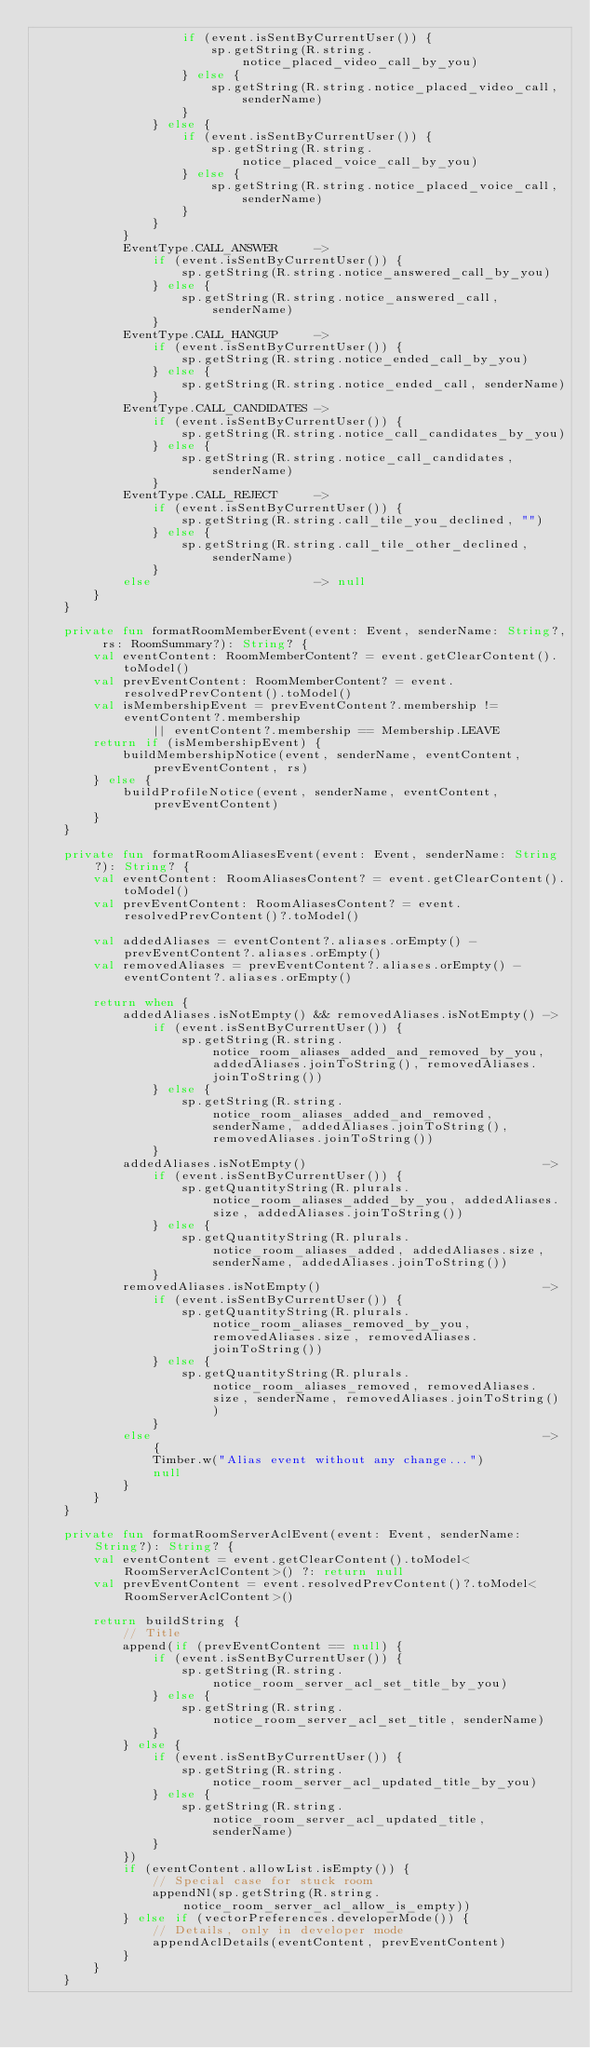Convert code to text. <code><loc_0><loc_0><loc_500><loc_500><_Kotlin_>                    if (event.isSentByCurrentUser()) {
                        sp.getString(R.string.notice_placed_video_call_by_you)
                    } else {
                        sp.getString(R.string.notice_placed_video_call, senderName)
                    }
                } else {
                    if (event.isSentByCurrentUser()) {
                        sp.getString(R.string.notice_placed_voice_call_by_you)
                    } else {
                        sp.getString(R.string.notice_placed_voice_call, senderName)
                    }
                }
            }
            EventType.CALL_ANSWER     ->
                if (event.isSentByCurrentUser()) {
                    sp.getString(R.string.notice_answered_call_by_you)
                } else {
                    sp.getString(R.string.notice_answered_call, senderName)
                }
            EventType.CALL_HANGUP     ->
                if (event.isSentByCurrentUser()) {
                    sp.getString(R.string.notice_ended_call_by_you)
                } else {
                    sp.getString(R.string.notice_ended_call, senderName)
                }
            EventType.CALL_CANDIDATES ->
                if (event.isSentByCurrentUser()) {
                    sp.getString(R.string.notice_call_candidates_by_you)
                } else {
                    sp.getString(R.string.notice_call_candidates, senderName)
                }
            EventType.CALL_REJECT     ->
                if (event.isSentByCurrentUser()) {
                    sp.getString(R.string.call_tile_you_declined, "")
                } else {
                    sp.getString(R.string.call_tile_other_declined, senderName)
                }
            else                      -> null
        }
    }

    private fun formatRoomMemberEvent(event: Event, senderName: String?, rs: RoomSummary?): String? {
        val eventContent: RoomMemberContent? = event.getClearContent().toModel()
        val prevEventContent: RoomMemberContent? = event.resolvedPrevContent().toModel()
        val isMembershipEvent = prevEventContent?.membership != eventContent?.membership
                || eventContent?.membership == Membership.LEAVE
        return if (isMembershipEvent) {
            buildMembershipNotice(event, senderName, eventContent, prevEventContent, rs)
        } else {
            buildProfileNotice(event, senderName, eventContent, prevEventContent)
        }
    }

    private fun formatRoomAliasesEvent(event: Event, senderName: String?): String? {
        val eventContent: RoomAliasesContent? = event.getClearContent().toModel()
        val prevEventContent: RoomAliasesContent? = event.resolvedPrevContent()?.toModel()

        val addedAliases = eventContent?.aliases.orEmpty() - prevEventContent?.aliases.orEmpty()
        val removedAliases = prevEventContent?.aliases.orEmpty() - eventContent?.aliases.orEmpty()

        return when {
            addedAliases.isNotEmpty() && removedAliases.isNotEmpty() ->
                if (event.isSentByCurrentUser()) {
                    sp.getString(R.string.notice_room_aliases_added_and_removed_by_you, addedAliases.joinToString(), removedAliases.joinToString())
                } else {
                    sp.getString(R.string.notice_room_aliases_added_and_removed, senderName, addedAliases.joinToString(), removedAliases.joinToString())
                }
            addedAliases.isNotEmpty()                                ->
                if (event.isSentByCurrentUser()) {
                    sp.getQuantityString(R.plurals.notice_room_aliases_added_by_you, addedAliases.size, addedAliases.joinToString())
                } else {
                    sp.getQuantityString(R.plurals.notice_room_aliases_added, addedAliases.size, senderName, addedAliases.joinToString())
                }
            removedAliases.isNotEmpty()                              ->
                if (event.isSentByCurrentUser()) {
                    sp.getQuantityString(R.plurals.notice_room_aliases_removed_by_you, removedAliases.size, removedAliases.joinToString())
                } else {
                    sp.getQuantityString(R.plurals.notice_room_aliases_removed, removedAliases.size, senderName, removedAliases.joinToString())
                }
            else                                                     -> {
                Timber.w("Alias event without any change...")
                null
            }
        }
    }

    private fun formatRoomServerAclEvent(event: Event, senderName: String?): String? {
        val eventContent = event.getClearContent().toModel<RoomServerAclContent>() ?: return null
        val prevEventContent = event.resolvedPrevContent()?.toModel<RoomServerAclContent>()

        return buildString {
            // Title
            append(if (prevEventContent == null) {
                if (event.isSentByCurrentUser()) {
                    sp.getString(R.string.notice_room_server_acl_set_title_by_you)
                } else {
                    sp.getString(R.string.notice_room_server_acl_set_title, senderName)
                }
            } else {
                if (event.isSentByCurrentUser()) {
                    sp.getString(R.string.notice_room_server_acl_updated_title_by_you)
                } else {
                    sp.getString(R.string.notice_room_server_acl_updated_title, senderName)
                }
            })
            if (eventContent.allowList.isEmpty()) {
                // Special case for stuck room
                appendNl(sp.getString(R.string.notice_room_server_acl_allow_is_empty))
            } else if (vectorPreferences.developerMode()) {
                // Details, only in developer mode
                appendAclDetails(eventContent, prevEventContent)
            }
        }
    }
</code> 